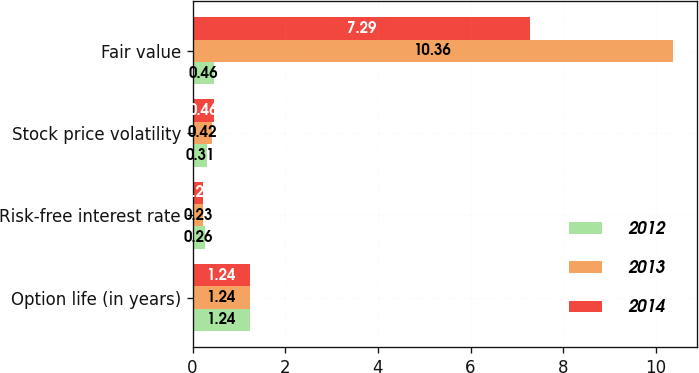Convert chart to OTSL. <chart><loc_0><loc_0><loc_500><loc_500><stacked_bar_chart><ecel><fcel>Option life (in years)<fcel>Risk-free interest rate<fcel>Stock price volatility<fcel>Fair value<nl><fcel>2012<fcel>1.24<fcel>0.26<fcel>0.31<fcel>0.46<nl><fcel>2013<fcel>1.24<fcel>0.23<fcel>0.42<fcel>10.36<nl><fcel>2014<fcel>1.24<fcel>0.22<fcel>0.46<fcel>7.29<nl></chart> 